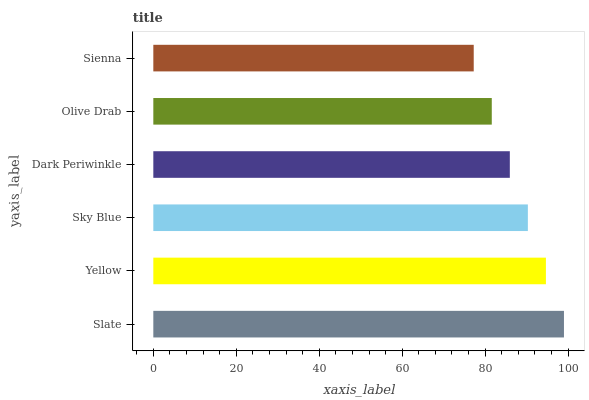Is Sienna the minimum?
Answer yes or no. Yes. Is Slate the maximum?
Answer yes or no. Yes. Is Yellow the minimum?
Answer yes or no. No. Is Yellow the maximum?
Answer yes or no. No. Is Slate greater than Yellow?
Answer yes or no. Yes. Is Yellow less than Slate?
Answer yes or no. Yes. Is Yellow greater than Slate?
Answer yes or no. No. Is Slate less than Yellow?
Answer yes or no. No. Is Sky Blue the high median?
Answer yes or no. Yes. Is Dark Periwinkle the low median?
Answer yes or no. Yes. Is Olive Drab the high median?
Answer yes or no. No. Is Sky Blue the low median?
Answer yes or no. No. 